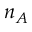<formula> <loc_0><loc_0><loc_500><loc_500>n _ { A }</formula> 